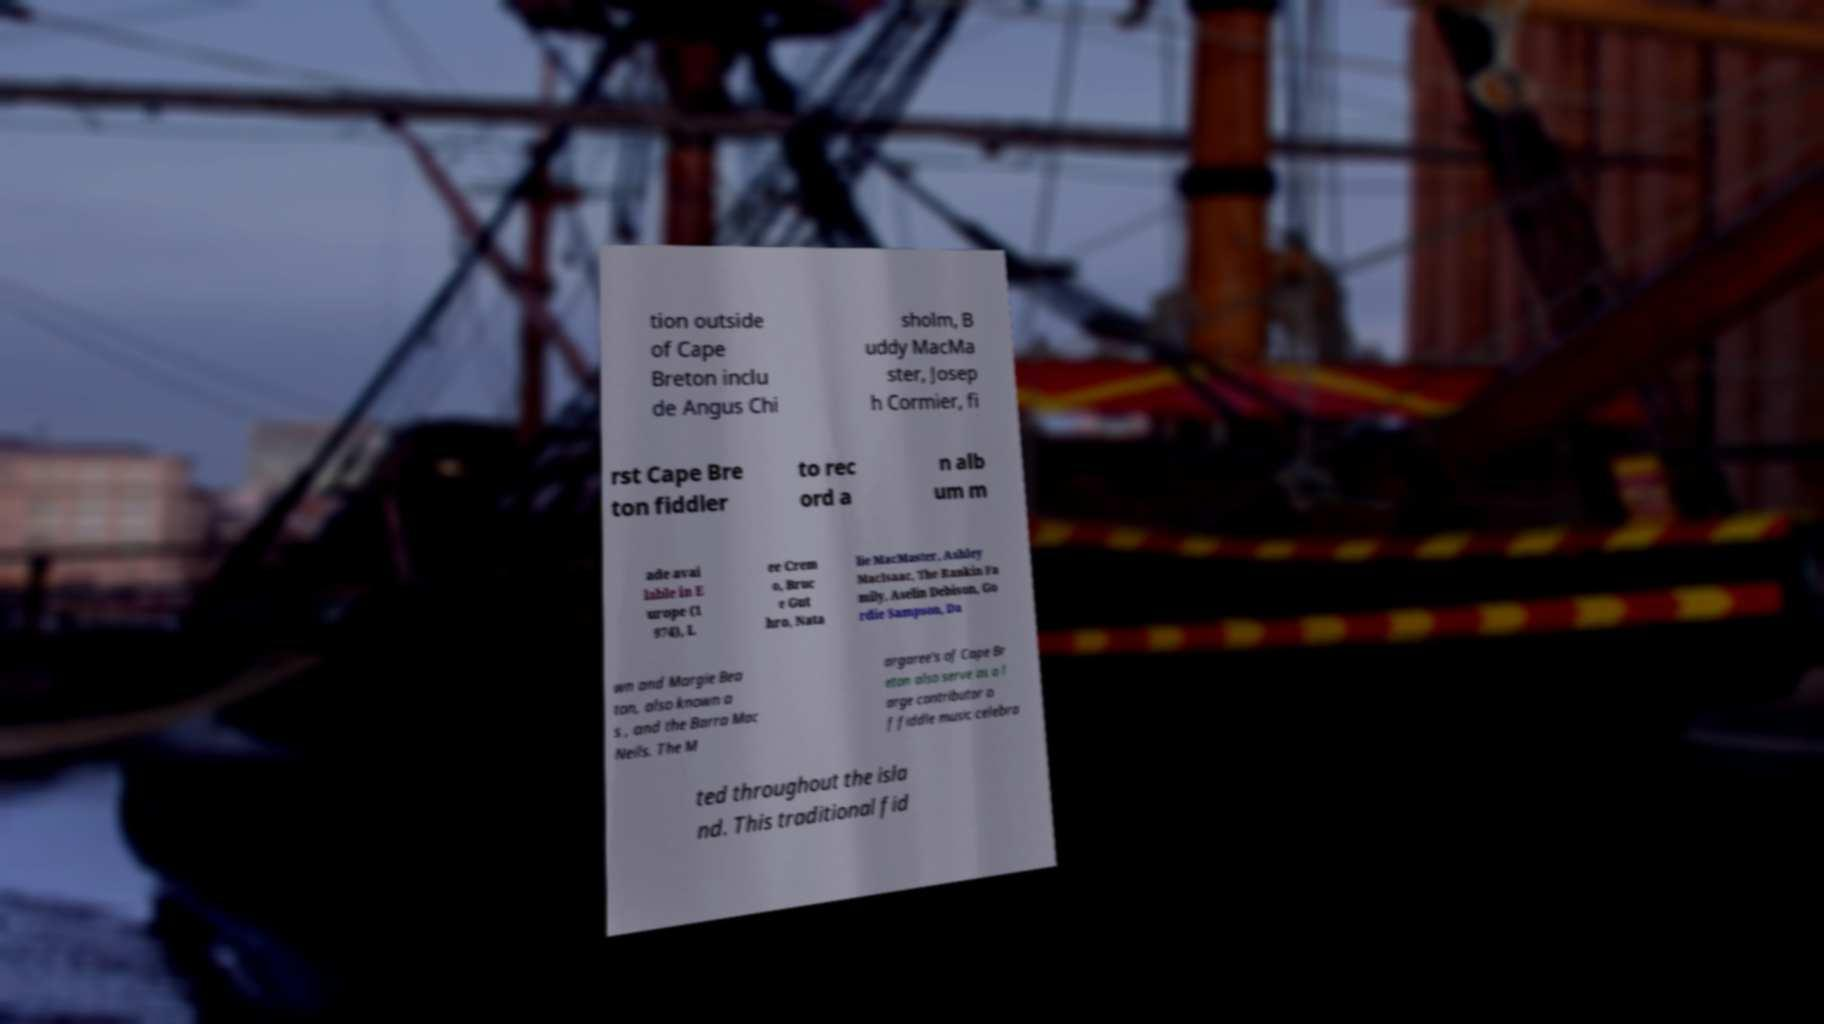Can you read and provide the text displayed in the image?This photo seems to have some interesting text. Can you extract and type it out for me? tion outside of Cape Breton inclu de Angus Chi sholm, B uddy MacMa ster, Josep h Cormier, fi rst Cape Bre ton fiddler to rec ord a n alb um m ade avai lable in E urope (1 974), L ee Crem o, Bruc e Gut hro, Nata lie MacMaster, Ashley MacIsaac, The Rankin Fa mily, Aselin Debison, Go rdie Sampson, Da wn and Margie Bea ton, also known a s , and the Barra Mac Neils. The M argaree's of Cape Br eton also serve as a l arge contributor o f fiddle music celebra ted throughout the isla nd. This traditional fid 